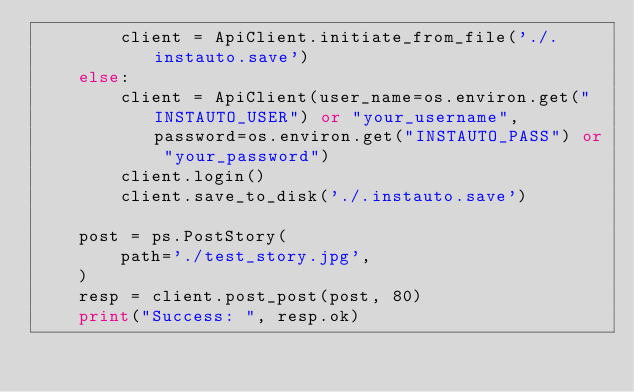<code> <loc_0><loc_0><loc_500><loc_500><_Python_>        client = ApiClient.initiate_from_file('./.instauto.save')
    else:
        client = ApiClient(user_name=os.environ.get("INSTAUTO_USER") or "your_username", password=os.environ.get("INSTAUTO_PASS") or "your_password")
        client.login()
        client.save_to_disk('./.instauto.save')

    post = ps.PostStory(
        path='./test_story.jpg',
    )
    resp = client.post_post(post, 80)
    print("Success: ", resp.ok)
</code> 